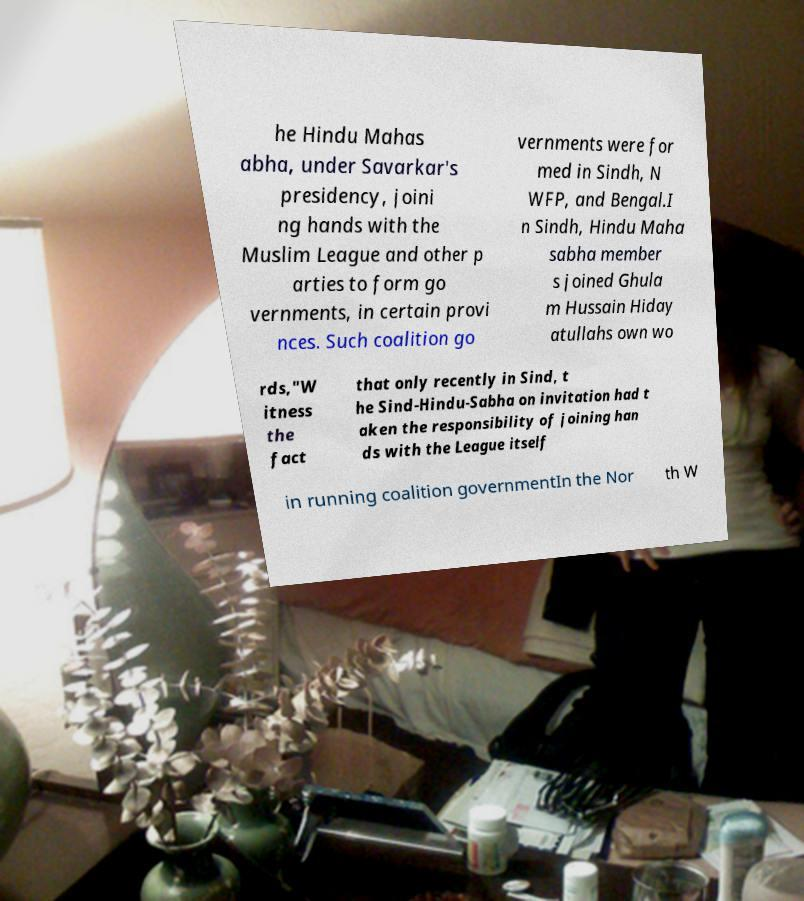Could you extract and type out the text from this image? he Hindu Mahas abha, under Savarkar's presidency, joini ng hands with the Muslim League and other p arties to form go vernments, in certain provi nces. Such coalition go vernments were for med in Sindh, N WFP, and Bengal.I n Sindh, Hindu Maha sabha member s joined Ghula m Hussain Hiday atullahs own wo rds,"W itness the fact that only recently in Sind, t he Sind-Hindu-Sabha on invitation had t aken the responsibility of joining han ds with the League itself in running coalition governmentIn the Nor th W 